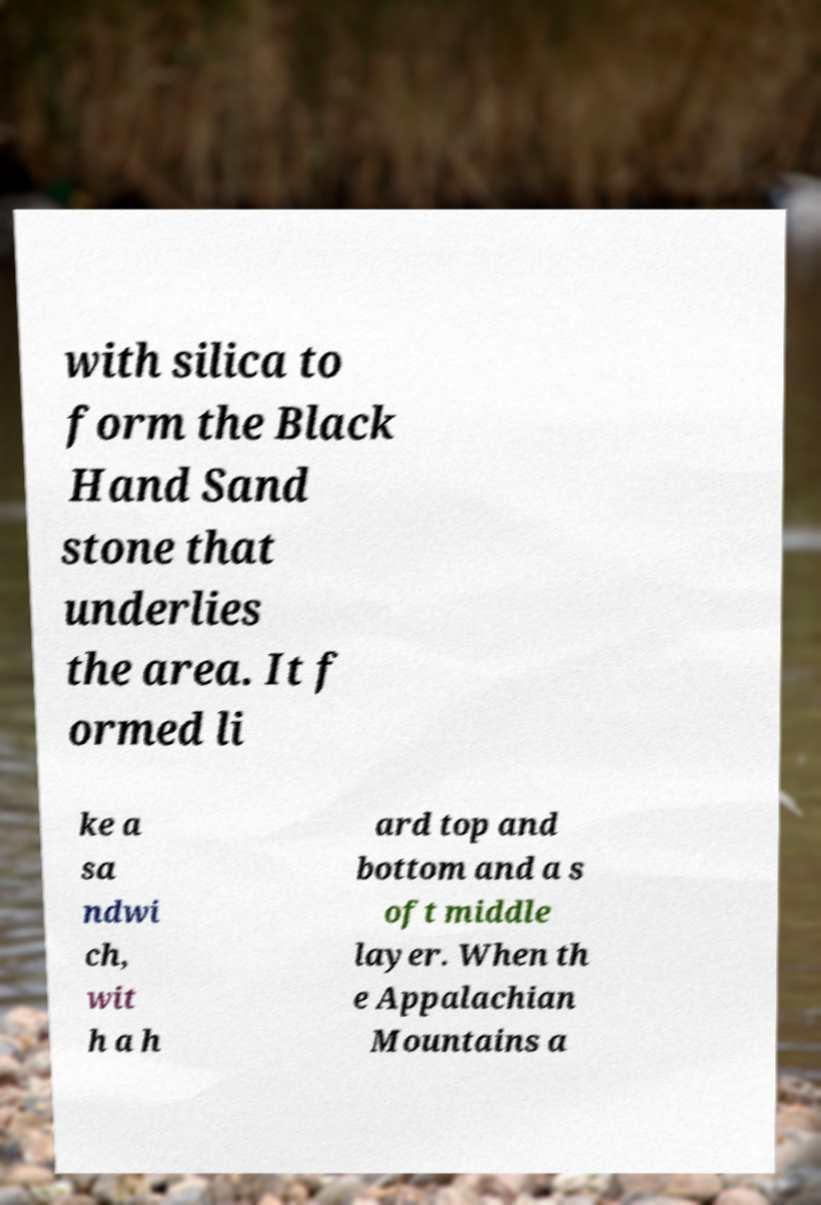Could you extract and type out the text from this image? with silica to form the Black Hand Sand stone that underlies the area. It f ormed li ke a sa ndwi ch, wit h a h ard top and bottom and a s oft middle layer. When th e Appalachian Mountains a 